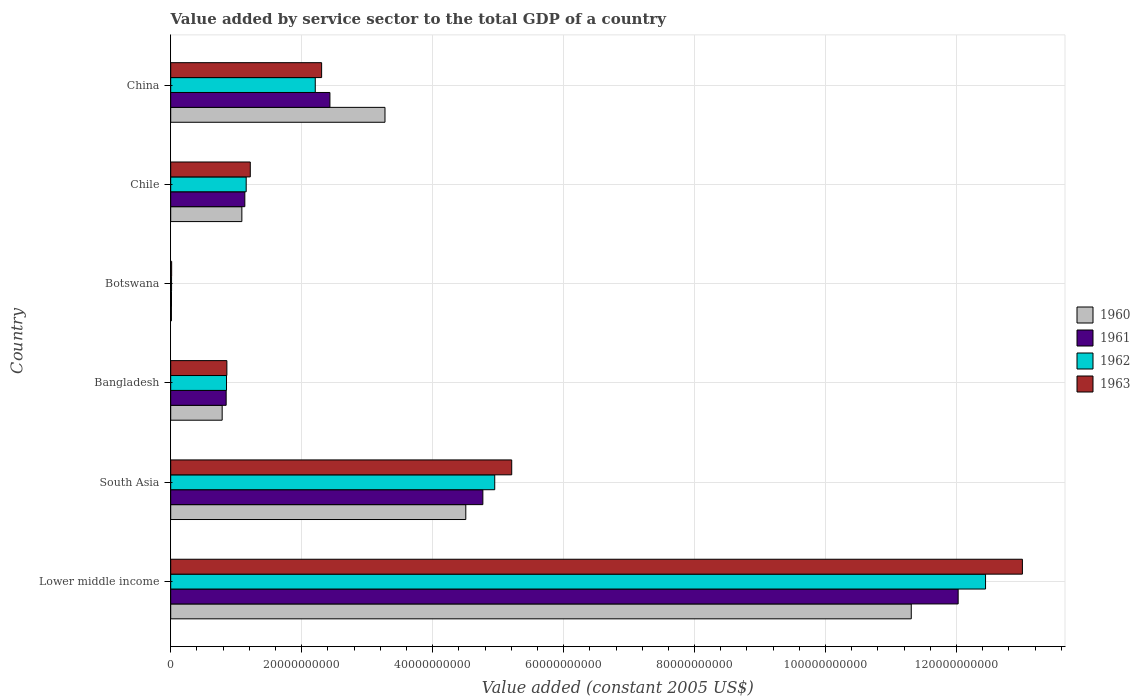Are the number of bars on each tick of the Y-axis equal?
Offer a terse response. Yes. What is the label of the 6th group of bars from the top?
Make the answer very short. Lower middle income. In how many cases, is the number of bars for a given country not equal to the number of legend labels?
Provide a succinct answer. 0. What is the value added by service sector in 1960 in Botswana?
Keep it short and to the point. 1.11e+08. Across all countries, what is the maximum value added by service sector in 1961?
Keep it short and to the point. 1.20e+11. Across all countries, what is the minimum value added by service sector in 1960?
Make the answer very short. 1.11e+08. In which country was the value added by service sector in 1961 maximum?
Ensure brevity in your answer.  Lower middle income. In which country was the value added by service sector in 1960 minimum?
Your answer should be very brief. Botswana. What is the total value added by service sector in 1961 in the graph?
Provide a succinct answer. 2.12e+11. What is the difference between the value added by service sector in 1962 in Bangladesh and that in South Asia?
Provide a succinct answer. -4.10e+1. What is the difference between the value added by service sector in 1961 in Botswana and the value added by service sector in 1960 in China?
Your response must be concise. -3.26e+1. What is the average value added by service sector in 1963 per country?
Keep it short and to the point. 3.77e+1. What is the difference between the value added by service sector in 1963 and value added by service sector in 1961 in Botswana?
Make the answer very short. 2.33e+07. What is the ratio of the value added by service sector in 1962 in Bangladesh to that in China?
Your response must be concise. 0.39. Is the value added by service sector in 1962 in Bangladesh less than that in Botswana?
Give a very brief answer. No. What is the difference between the highest and the second highest value added by service sector in 1960?
Give a very brief answer. 6.80e+1. What is the difference between the highest and the lowest value added by service sector in 1961?
Offer a terse response. 1.20e+11. Is it the case that in every country, the sum of the value added by service sector in 1960 and value added by service sector in 1962 is greater than the sum of value added by service sector in 1963 and value added by service sector in 1961?
Keep it short and to the point. No. What does the 1st bar from the top in China represents?
Offer a terse response. 1963. What does the 4th bar from the bottom in Botswana represents?
Make the answer very short. 1963. Is it the case that in every country, the sum of the value added by service sector in 1963 and value added by service sector in 1962 is greater than the value added by service sector in 1961?
Your answer should be very brief. Yes. How many bars are there?
Your response must be concise. 24. How many countries are there in the graph?
Your answer should be compact. 6. What is the difference between two consecutive major ticks on the X-axis?
Make the answer very short. 2.00e+1. Does the graph contain grids?
Keep it short and to the point. Yes. What is the title of the graph?
Give a very brief answer. Value added by service sector to the total GDP of a country. What is the label or title of the X-axis?
Keep it short and to the point. Value added (constant 2005 US$). What is the label or title of the Y-axis?
Give a very brief answer. Country. What is the Value added (constant 2005 US$) of 1960 in Lower middle income?
Provide a succinct answer. 1.13e+11. What is the Value added (constant 2005 US$) of 1961 in Lower middle income?
Your answer should be very brief. 1.20e+11. What is the Value added (constant 2005 US$) in 1962 in Lower middle income?
Keep it short and to the point. 1.24e+11. What is the Value added (constant 2005 US$) in 1963 in Lower middle income?
Make the answer very short. 1.30e+11. What is the Value added (constant 2005 US$) in 1960 in South Asia?
Make the answer very short. 4.51e+1. What is the Value added (constant 2005 US$) in 1961 in South Asia?
Provide a succinct answer. 4.77e+1. What is the Value added (constant 2005 US$) in 1962 in South Asia?
Offer a terse response. 4.95e+1. What is the Value added (constant 2005 US$) in 1963 in South Asia?
Give a very brief answer. 5.21e+1. What is the Value added (constant 2005 US$) in 1960 in Bangladesh?
Make the answer very short. 7.86e+09. What is the Value added (constant 2005 US$) in 1961 in Bangladesh?
Offer a very short reply. 8.47e+09. What is the Value added (constant 2005 US$) of 1962 in Bangladesh?
Provide a short and direct response. 8.52e+09. What is the Value added (constant 2005 US$) in 1963 in Bangladesh?
Give a very brief answer. 8.58e+09. What is the Value added (constant 2005 US$) in 1960 in Botswana?
Keep it short and to the point. 1.11e+08. What is the Value added (constant 2005 US$) of 1961 in Botswana?
Offer a terse response. 1.22e+08. What is the Value added (constant 2005 US$) in 1962 in Botswana?
Keep it short and to the point. 1.32e+08. What is the Value added (constant 2005 US$) in 1963 in Botswana?
Your answer should be compact. 1.45e+08. What is the Value added (constant 2005 US$) of 1960 in Chile?
Offer a very short reply. 1.09e+1. What is the Value added (constant 2005 US$) in 1961 in Chile?
Make the answer very short. 1.13e+1. What is the Value added (constant 2005 US$) of 1962 in Chile?
Your answer should be compact. 1.15e+1. What is the Value added (constant 2005 US$) in 1963 in Chile?
Make the answer very short. 1.22e+1. What is the Value added (constant 2005 US$) of 1960 in China?
Your answer should be very brief. 3.27e+1. What is the Value added (constant 2005 US$) in 1961 in China?
Give a very brief answer. 2.43e+1. What is the Value added (constant 2005 US$) of 1962 in China?
Provide a short and direct response. 2.21e+1. What is the Value added (constant 2005 US$) in 1963 in China?
Make the answer very short. 2.30e+1. Across all countries, what is the maximum Value added (constant 2005 US$) in 1960?
Your answer should be very brief. 1.13e+11. Across all countries, what is the maximum Value added (constant 2005 US$) of 1961?
Offer a terse response. 1.20e+11. Across all countries, what is the maximum Value added (constant 2005 US$) in 1962?
Make the answer very short. 1.24e+11. Across all countries, what is the maximum Value added (constant 2005 US$) in 1963?
Offer a very short reply. 1.30e+11. Across all countries, what is the minimum Value added (constant 2005 US$) of 1960?
Make the answer very short. 1.11e+08. Across all countries, what is the minimum Value added (constant 2005 US$) of 1961?
Offer a terse response. 1.22e+08. Across all countries, what is the minimum Value added (constant 2005 US$) in 1962?
Provide a short and direct response. 1.32e+08. Across all countries, what is the minimum Value added (constant 2005 US$) in 1963?
Give a very brief answer. 1.45e+08. What is the total Value added (constant 2005 US$) in 1960 in the graph?
Make the answer very short. 2.10e+11. What is the total Value added (constant 2005 US$) in 1961 in the graph?
Your response must be concise. 2.12e+11. What is the total Value added (constant 2005 US$) in 1962 in the graph?
Make the answer very short. 2.16e+11. What is the total Value added (constant 2005 US$) of 1963 in the graph?
Give a very brief answer. 2.26e+11. What is the difference between the Value added (constant 2005 US$) in 1960 in Lower middle income and that in South Asia?
Make the answer very short. 6.80e+1. What is the difference between the Value added (constant 2005 US$) in 1961 in Lower middle income and that in South Asia?
Your answer should be very brief. 7.26e+1. What is the difference between the Value added (constant 2005 US$) of 1962 in Lower middle income and that in South Asia?
Keep it short and to the point. 7.50e+1. What is the difference between the Value added (constant 2005 US$) in 1963 in Lower middle income and that in South Asia?
Ensure brevity in your answer.  7.80e+1. What is the difference between the Value added (constant 2005 US$) in 1960 in Lower middle income and that in Bangladesh?
Provide a succinct answer. 1.05e+11. What is the difference between the Value added (constant 2005 US$) in 1961 in Lower middle income and that in Bangladesh?
Provide a succinct answer. 1.12e+11. What is the difference between the Value added (constant 2005 US$) of 1962 in Lower middle income and that in Bangladesh?
Provide a succinct answer. 1.16e+11. What is the difference between the Value added (constant 2005 US$) in 1963 in Lower middle income and that in Bangladesh?
Your response must be concise. 1.21e+11. What is the difference between the Value added (constant 2005 US$) of 1960 in Lower middle income and that in Botswana?
Ensure brevity in your answer.  1.13e+11. What is the difference between the Value added (constant 2005 US$) of 1961 in Lower middle income and that in Botswana?
Give a very brief answer. 1.20e+11. What is the difference between the Value added (constant 2005 US$) in 1962 in Lower middle income and that in Botswana?
Keep it short and to the point. 1.24e+11. What is the difference between the Value added (constant 2005 US$) of 1963 in Lower middle income and that in Botswana?
Give a very brief answer. 1.30e+11. What is the difference between the Value added (constant 2005 US$) in 1960 in Lower middle income and that in Chile?
Offer a terse response. 1.02e+11. What is the difference between the Value added (constant 2005 US$) in 1961 in Lower middle income and that in Chile?
Offer a very short reply. 1.09e+11. What is the difference between the Value added (constant 2005 US$) in 1962 in Lower middle income and that in Chile?
Offer a very short reply. 1.13e+11. What is the difference between the Value added (constant 2005 US$) of 1963 in Lower middle income and that in Chile?
Provide a short and direct response. 1.18e+11. What is the difference between the Value added (constant 2005 US$) in 1960 in Lower middle income and that in China?
Provide a succinct answer. 8.04e+1. What is the difference between the Value added (constant 2005 US$) of 1961 in Lower middle income and that in China?
Provide a succinct answer. 9.59e+1. What is the difference between the Value added (constant 2005 US$) in 1962 in Lower middle income and that in China?
Ensure brevity in your answer.  1.02e+11. What is the difference between the Value added (constant 2005 US$) in 1963 in Lower middle income and that in China?
Your response must be concise. 1.07e+11. What is the difference between the Value added (constant 2005 US$) of 1960 in South Asia and that in Bangladesh?
Keep it short and to the point. 3.72e+1. What is the difference between the Value added (constant 2005 US$) in 1961 in South Asia and that in Bangladesh?
Provide a succinct answer. 3.92e+1. What is the difference between the Value added (constant 2005 US$) in 1962 in South Asia and that in Bangladesh?
Keep it short and to the point. 4.10e+1. What is the difference between the Value added (constant 2005 US$) of 1963 in South Asia and that in Bangladesh?
Your response must be concise. 4.35e+1. What is the difference between the Value added (constant 2005 US$) of 1960 in South Asia and that in Botswana?
Keep it short and to the point. 4.50e+1. What is the difference between the Value added (constant 2005 US$) in 1961 in South Asia and that in Botswana?
Ensure brevity in your answer.  4.75e+1. What is the difference between the Value added (constant 2005 US$) of 1962 in South Asia and that in Botswana?
Provide a succinct answer. 4.93e+1. What is the difference between the Value added (constant 2005 US$) in 1963 in South Asia and that in Botswana?
Your answer should be compact. 5.19e+1. What is the difference between the Value added (constant 2005 US$) of 1960 in South Asia and that in Chile?
Your response must be concise. 3.42e+1. What is the difference between the Value added (constant 2005 US$) of 1961 in South Asia and that in Chile?
Give a very brief answer. 3.63e+1. What is the difference between the Value added (constant 2005 US$) in 1962 in South Asia and that in Chile?
Provide a short and direct response. 3.80e+1. What is the difference between the Value added (constant 2005 US$) of 1963 in South Asia and that in Chile?
Make the answer very short. 3.99e+1. What is the difference between the Value added (constant 2005 US$) of 1960 in South Asia and that in China?
Provide a short and direct response. 1.23e+1. What is the difference between the Value added (constant 2005 US$) in 1961 in South Asia and that in China?
Keep it short and to the point. 2.34e+1. What is the difference between the Value added (constant 2005 US$) of 1962 in South Asia and that in China?
Provide a short and direct response. 2.74e+1. What is the difference between the Value added (constant 2005 US$) of 1963 in South Asia and that in China?
Your answer should be compact. 2.90e+1. What is the difference between the Value added (constant 2005 US$) in 1960 in Bangladesh and that in Botswana?
Your answer should be compact. 7.75e+09. What is the difference between the Value added (constant 2005 US$) of 1961 in Bangladesh and that in Botswana?
Your response must be concise. 8.35e+09. What is the difference between the Value added (constant 2005 US$) of 1962 in Bangladesh and that in Botswana?
Offer a terse response. 8.39e+09. What is the difference between the Value added (constant 2005 US$) in 1963 in Bangladesh and that in Botswana?
Your answer should be very brief. 8.43e+09. What is the difference between the Value added (constant 2005 US$) of 1960 in Bangladesh and that in Chile?
Provide a short and direct response. -3.01e+09. What is the difference between the Value added (constant 2005 US$) in 1961 in Bangladesh and that in Chile?
Provide a succinct answer. -2.85e+09. What is the difference between the Value added (constant 2005 US$) in 1962 in Bangladesh and that in Chile?
Make the answer very short. -3.00e+09. What is the difference between the Value added (constant 2005 US$) of 1963 in Bangladesh and that in Chile?
Make the answer very short. -3.58e+09. What is the difference between the Value added (constant 2005 US$) in 1960 in Bangladesh and that in China?
Offer a terse response. -2.49e+1. What is the difference between the Value added (constant 2005 US$) in 1961 in Bangladesh and that in China?
Your answer should be compact. -1.58e+1. What is the difference between the Value added (constant 2005 US$) in 1962 in Bangladesh and that in China?
Offer a terse response. -1.36e+1. What is the difference between the Value added (constant 2005 US$) of 1963 in Bangladesh and that in China?
Provide a succinct answer. -1.45e+1. What is the difference between the Value added (constant 2005 US$) of 1960 in Botswana and that in Chile?
Keep it short and to the point. -1.08e+1. What is the difference between the Value added (constant 2005 US$) in 1961 in Botswana and that in Chile?
Your answer should be very brief. -1.12e+1. What is the difference between the Value added (constant 2005 US$) of 1962 in Botswana and that in Chile?
Offer a terse response. -1.14e+1. What is the difference between the Value added (constant 2005 US$) of 1963 in Botswana and that in Chile?
Your response must be concise. -1.20e+1. What is the difference between the Value added (constant 2005 US$) in 1960 in Botswana and that in China?
Offer a very short reply. -3.26e+1. What is the difference between the Value added (constant 2005 US$) in 1961 in Botswana and that in China?
Offer a terse response. -2.42e+1. What is the difference between the Value added (constant 2005 US$) in 1962 in Botswana and that in China?
Your response must be concise. -2.19e+1. What is the difference between the Value added (constant 2005 US$) in 1963 in Botswana and that in China?
Provide a succinct answer. -2.29e+1. What is the difference between the Value added (constant 2005 US$) in 1960 in Chile and that in China?
Your response must be concise. -2.19e+1. What is the difference between the Value added (constant 2005 US$) in 1961 in Chile and that in China?
Offer a terse response. -1.30e+1. What is the difference between the Value added (constant 2005 US$) in 1962 in Chile and that in China?
Offer a terse response. -1.05e+1. What is the difference between the Value added (constant 2005 US$) of 1963 in Chile and that in China?
Provide a short and direct response. -1.09e+1. What is the difference between the Value added (constant 2005 US$) of 1960 in Lower middle income and the Value added (constant 2005 US$) of 1961 in South Asia?
Provide a short and direct response. 6.54e+1. What is the difference between the Value added (constant 2005 US$) in 1960 in Lower middle income and the Value added (constant 2005 US$) in 1962 in South Asia?
Keep it short and to the point. 6.36e+1. What is the difference between the Value added (constant 2005 US$) of 1960 in Lower middle income and the Value added (constant 2005 US$) of 1963 in South Asia?
Your response must be concise. 6.10e+1. What is the difference between the Value added (constant 2005 US$) in 1961 in Lower middle income and the Value added (constant 2005 US$) in 1962 in South Asia?
Your answer should be compact. 7.08e+1. What is the difference between the Value added (constant 2005 US$) in 1961 in Lower middle income and the Value added (constant 2005 US$) in 1963 in South Asia?
Offer a very short reply. 6.82e+1. What is the difference between the Value added (constant 2005 US$) in 1962 in Lower middle income and the Value added (constant 2005 US$) in 1963 in South Asia?
Give a very brief answer. 7.24e+1. What is the difference between the Value added (constant 2005 US$) of 1960 in Lower middle income and the Value added (constant 2005 US$) of 1961 in Bangladesh?
Make the answer very short. 1.05e+11. What is the difference between the Value added (constant 2005 US$) in 1960 in Lower middle income and the Value added (constant 2005 US$) in 1962 in Bangladesh?
Keep it short and to the point. 1.05e+11. What is the difference between the Value added (constant 2005 US$) in 1960 in Lower middle income and the Value added (constant 2005 US$) in 1963 in Bangladesh?
Provide a succinct answer. 1.05e+11. What is the difference between the Value added (constant 2005 US$) in 1961 in Lower middle income and the Value added (constant 2005 US$) in 1962 in Bangladesh?
Your answer should be very brief. 1.12e+11. What is the difference between the Value added (constant 2005 US$) of 1961 in Lower middle income and the Value added (constant 2005 US$) of 1963 in Bangladesh?
Make the answer very short. 1.12e+11. What is the difference between the Value added (constant 2005 US$) in 1962 in Lower middle income and the Value added (constant 2005 US$) in 1963 in Bangladesh?
Offer a very short reply. 1.16e+11. What is the difference between the Value added (constant 2005 US$) in 1960 in Lower middle income and the Value added (constant 2005 US$) in 1961 in Botswana?
Offer a terse response. 1.13e+11. What is the difference between the Value added (constant 2005 US$) in 1960 in Lower middle income and the Value added (constant 2005 US$) in 1962 in Botswana?
Provide a succinct answer. 1.13e+11. What is the difference between the Value added (constant 2005 US$) of 1960 in Lower middle income and the Value added (constant 2005 US$) of 1963 in Botswana?
Offer a terse response. 1.13e+11. What is the difference between the Value added (constant 2005 US$) of 1961 in Lower middle income and the Value added (constant 2005 US$) of 1962 in Botswana?
Your answer should be very brief. 1.20e+11. What is the difference between the Value added (constant 2005 US$) of 1961 in Lower middle income and the Value added (constant 2005 US$) of 1963 in Botswana?
Keep it short and to the point. 1.20e+11. What is the difference between the Value added (constant 2005 US$) of 1962 in Lower middle income and the Value added (constant 2005 US$) of 1963 in Botswana?
Your response must be concise. 1.24e+11. What is the difference between the Value added (constant 2005 US$) of 1960 in Lower middle income and the Value added (constant 2005 US$) of 1961 in Chile?
Ensure brevity in your answer.  1.02e+11. What is the difference between the Value added (constant 2005 US$) of 1960 in Lower middle income and the Value added (constant 2005 US$) of 1962 in Chile?
Offer a terse response. 1.02e+11. What is the difference between the Value added (constant 2005 US$) of 1960 in Lower middle income and the Value added (constant 2005 US$) of 1963 in Chile?
Provide a short and direct response. 1.01e+11. What is the difference between the Value added (constant 2005 US$) in 1961 in Lower middle income and the Value added (constant 2005 US$) in 1962 in Chile?
Ensure brevity in your answer.  1.09e+11. What is the difference between the Value added (constant 2005 US$) in 1961 in Lower middle income and the Value added (constant 2005 US$) in 1963 in Chile?
Your response must be concise. 1.08e+11. What is the difference between the Value added (constant 2005 US$) of 1962 in Lower middle income and the Value added (constant 2005 US$) of 1963 in Chile?
Your response must be concise. 1.12e+11. What is the difference between the Value added (constant 2005 US$) in 1960 in Lower middle income and the Value added (constant 2005 US$) in 1961 in China?
Provide a short and direct response. 8.88e+1. What is the difference between the Value added (constant 2005 US$) in 1960 in Lower middle income and the Value added (constant 2005 US$) in 1962 in China?
Your answer should be compact. 9.10e+1. What is the difference between the Value added (constant 2005 US$) in 1960 in Lower middle income and the Value added (constant 2005 US$) in 1963 in China?
Your response must be concise. 9.00e+1. What is the difference between the Value added (constant 2005 US$) of 1961 in Lower middle income and the Value added (constant 2005 US$) of 1962 in China?
Provide a short and direct response. 9.82e+1. What is the difference between the Value added (constant 2005 US$) in 1961 in Lower middle income and the Value added (constant 2005 US$) in 1963 in China?
Your answer should be very brief. 9.72e+1. What is the difference between the Value added (constant 2005 US$) in 1962 in Lower middle income and the Value added (constant 2005 US$) in 1963 in China?
Provide a succinct answer. 1.01e+11. What is the difference between the Value added (constant 2005 US$) in 1960 in South Asia and the Value added (constant 2005 US$) in 1961 in Bangladesh?
Make the answer very short. 3.66e+1. What is the difference between the Value added (constant 2005 US$) of 1960 in South Asia and the Value added (constant 2005 US$) of 1962 in Bangladesh?
Your answer should be very brief. 3.65e+1. What is the difference between the Value added (constant 2005 US$) of 1960 in South Asia and the Value added (constant 2005 US$) of 1963 in Bangladesh?
Provide a short and direct response. 3.65e+1. What is the difference between the Value added (constant 2005 US$) of 1961 in South Asia and the Value added (constant 2005 US$) of 1962 in Bangladesh?
Give a very brief answer. 3.91e+1. What is the difference between the Value added (constant 2005 US$) in 1961 in South Asia and the Value added (constant 2005 US$) in 1963 in Bangladesh?
Your answer should be compact. 3.91e+1. What is the difference between the Value added (constant 2005 US$) in 1962 in South Asia and the Value added (constant 2005 US$) in 1963 in Bangladesh?
Your answer should be compact. 4.09e+1. What is the difference between the Value added (constant 2005 US$) in 1960 in South Asia and the Value added (constant 2005 US$) in 1961 in Botswana?
Offer a terse response. 4.49e+1. What is the difference between the Value added (constant 2005 US$) of 1960 in South Asia and the Value added (constant 2005 US$) of 1962 in Botswana?
Your response must be concise. 4.49e+1. What is the difference between the Value added (constant 2005 US$) of 1960 in South Asia and the Value added (constant 2005 US$) of 1963 in Botswana?
Your answer should be compact. 4.49e+1. What is the difference between the Value added (constant 2005 US$) in 1961 in South Asia and the Value added (constant 2005 US$) in 1962 in Botswana?
Ensure brevity in your answer.  4.75e+1. What is the difference between the Value added (constant 2005 US$) in 1961 in South Asia and the Value added (constant 2005 US$) in 1963 in Botswana?
Offer a very short reply. 4.75e+1. What is the difference between the Value added (constant 2005 US$) of 1962 in South Asia and the Value added (constant 2005 US$) of 1963 in Botswana?
Your answer should be very brief. 4.93e+1. What is the difference between the Value added (constant 2005 US$) in 1960 in South Asia and the Value added (constant 2005 US$) in 1961 in Chile?
Make the answer very short. 3.37e+1. What is the difference between the Value added (constant 2005 US$) of 1960 in South Asia and the Value added (constant 2005 US$) of 1962 in Chile?
Your answer should be compact. 3.35e+1. What is the difference between the Value added (constant 2005 US$) in 1960 in South Asia and the Value added (constant 2005 US$) in 1963 in Chile?
Offer a very short reply. 3.29e+1. What is the difference between the Value added (constant 2005 US$) of 1961 in South Asia and the Value added (constant 2005 US$) of 1962 in Chile?
Provide a succinct answer. 3.61e+1. What is the difference between the Value added (constant 2005 US$) of 1961 in South Asia and the Value added (constant 2005 US$) of 1963 in Chile?
Offer a very short reply. 3.55e+1. What is the difference between the Value added (constant 2005 US$) of 1962 in South Asia and the Value added (constant 2005 US$) of 1963 in Chile?
Provide a succinct answer. 3.73e+1. What is the difference between the Value added (constant 2005 US$) in 1960 in South Asia and the Value added (constant 2005 US$) in 1961 in China?
Make the answer very short. 2.08e+1. What is the difference between the Value added (constant 2005 US$) in 1960 in South Asia and the Value added (constant 2005 US$) in 1962 in China?
Make the answer very short. 2.30e+1. What is the difference between the Value added (constant 2005 US$) of 1960 in South Asia and the Value added (constant 2005 US$) of 1963 in China?
Provide a short and direct response. 2.20e+1. What is the difference between the Value added (constant 2005 US$) of 1961 in South Asia and the Value added (constant 2005 US$) of 1962 in China?
Ensure brevity in your answer.  2.56e+1. What is the difference between the Value added (constant 2005 US$) in 1961 in South Asia and the Value added (constant 2005 US$) in 1963 in China?
Your answer should be compact. 2.46e+1. What is the difference between the Value added (constant 2005 US$) of 1962 in South Asia and the Value added (constant 2005 US$) of 1963 in China?
Give a very brief answer. 2.64e+1. What is the difference between the Value added (constant 2005 US$) of 1960 in Bangladesh and the Value added (constant 2005 US$) of 1961 in Botswana?
Offer a very short reply. 7.74e+09. What is the difference between the Value added (constant 2005 US$) of 1960 in Bangladesh and the Value added (constant 2005 US$) of 1962 in Botswana?
Your answer should be compact. 7.73e+09. What is the difference between the Value added (constant 2005 US$) of 1960 in Bangladesh and the Value added (constant 2005 US$) of 1963 in Botswana?
Give a very brief answer. 7.72e+09. What is the difference between the Value added (constant 2005 US$) of 1961 in Bangladesh and the Value added (constant 2005 US$) of 1962 in Botswana?
Give a very brief answer. 8.34e+09. What is the difference between the Value added (constant 2005 US$) in 1961 in Bangladesh and the Value added (constant 2005 US$) in 1963 in Botswana?
Make the answer very short. 8.32e+09. What is the difference between the Value added (constant 2005 US$) in 1962 in Bangladesh and the Value added (constant 2005 US$) in 1963 in Botswana?
Offer a terse response. 8.38e+09. What is the difference between the Value added (constant 2005 US$) of 1960 in Bangladesh and the Value added (constant 2005 US$) of 1961 in Chile?
Your response must be concise. -3.46e+09. What is the difference between the Value added (constant 2005 US$) in 1960 in Bangladesh and the Value added (constant 2005 US$) in 1962 in Chile?
Your response must be concise. -3.67e+09. What is the difference between the Value added (constant 2005 US$) of 1960 in Bangladesh and the Value added (constant 2005 US$) of 1963 in Chile?
Make the answer very short. -4.29e+09. What is the difference between the Value added (constant 2005 US$) of 1961 in Bangladesh and the Value added (constant 2005 US$) of 1962 in Chile?
Provide a succinct answer. -3.06e+09. What is the difference between the Value added (constant 2005 US$) of 1961 in Bangladesh and the Value added (constant 2005 US$) of 1963 in Chile?
Your answer should be very brief. -3.68e+09. What is the difference between the Value added (constant 2005 US$) of 1962 in Bangladesh and the Value added (constant 2005 US$) of 1963 in Chile?
Provide a succinct answer. -3.63e+09. What is the difference between the Value added (constant 2005 US$) in 1960 in Bangladesh and the Value added (constant 2005 US$) in 1961 in China?
Offer a very short reply. -1.65e+1. What is the difference between the Value added (constant 2005 US$) in 1960 in Bangladesh and the Value added (constant 2005 US$) in 1962 in China?
Ensure brevity in your answer.  -1.42e+1. What is the difference between the Value added (constant 2005 US$) in 1960 in Bangladesh and the Value added (constant 2005 US$) in 1963 in China?
Provide a short and direct response. -1.52e+1. What is the difference between the Value added (constant 2005 US$) in 1961 in Bangladesh and the Value added (constant 2005 US$) in 1962 in China?
Give a very brief answer. -1.36e+1. What is the difference between the Value added (constant 2005 US$) of 1961 in Bangladesh and the Value added (constant 2005 US$) of 1963 in China?
Keep it short and to the point. -1.46e+1. What is the difference between the Value added (constant 2005 US$) of 1962 in Bangladesh and the Value added (constant 2005 US$) of 1963 in China?
Ensure brevity in your answer.  -1.45e+1. What is the difference between the Value added (constant 2005 US$) in 1960 in Botswana and the Value added (constant 2005 US$) in 1961 in Chile?
Your response must be concise. -1.12e+1. What is the difference between the Value added (constant 2005 US$) of 1960 in Botswana and the Value added (constant 2005 US$) of 1962 in Chile?
Provide a succinct answer. -1.14e+1. What is the difference between the Value added (constant 2005 US$) of 1960 in Botswana and the Value added (constant 2005 US$) of 1963 in Chile?
Ensure brevity in your answer.  -1.20e+1. What is the difference between the Value added (constant 2005 US$) in 1961 in Botswana and the Value added (constant 2005 US$) in 1962 in Chile?
Ensure brevity in your answer.  -1.14e+1. What is the difference between the Value added (constant 2005 US$) in 1961 in Botswana and the Value added (constant 2005 US$) in 1963 in Chile?
Your response must be concise. -1.20e+1. What is the difference between the Value added (constant 2005 US$) of 1962 in Botswana and the Value added (constant 2005 US$) of 1963 in Chile?
Ensure brevity in your answer.  -1.20e+1. What is the difference between the Value added (constant 2005 US$) of 1960 in Botswana and the Value added (constant 2005 US$) of 1961 in China?
Provide a succinct answer. -2.42e+1. What is the difference between the Value added (constant 2005 US$) of 1960 in Botswana and the Value added (constant 2005 US$) of 1962 in China?
Ensure brevity in your answer.  -2.20e+1. What is the difference between the Value added (constant 2005 US$) of 1960 in Botswana and the Value added (constant 2005 US$) of 1963 in China?
Make the answer very short. -2.29e+1. What is the difference between the Value added (constant 2005 US$) of 1961 in Botswana and the Value added (constant 2005 US$) of 1962 in China?
Your response must be concise. -2.20e+1. What is the difference between the Value added (constant 2005 US$) in 1961 in Botswana and the Value added (constant 2005 US$) in 1963 in China?
Keep it short and to the point. -2.29e+1. What is the difference between the Value added (constant 2005 US$) in 1962 in Botswana and the Value added (constant 2005 US$) in 1963 in China?
Offer a terse response. -2.29e+1. What is the difference between the Value added (constant 2005 US$) in 1960 in Chile and the Value added (constant 2005 US$) in 1961 in China?
Make the answer very short. -1.34e+1. What is the difference between the Value added (constant 2005 US$) of 1960 in Chile and the Value added (constant 2005 US$) of 1962 in China?
Ensure brevity in your answer.  -1.12e+1. What is the difference between the Value added (constant 2005 US$) in 1960 in Chile and the Value added (constant 2005 US$) in 1963 in China?
Make the answer very short. -1.22e+1. What is the difference between the Value added (constant 2005 US$) in 1961 in Chile and the Value added (constant 2005 US$) in 1962 in China?
Ensure brevity in your answer.  -1.08e+1. What is the difference between the Value added (constant 2005 US$) of 1961 in Chile and the Value added (constant 2005 US$) of 1963 in China?
Provide a succinct answer. -1.17e+1. What is the difference between the Value added (constant 2005 US$) of 1962 in Chile and the Value added (constant 2005 US$) of 1963 in China?
Ensure brevity in your answer.  -1.15e+1. What is the average Value added (constant 2005 US$) in 1960 per country?
Make the answer very short. 3.50e+1. What is the average Value added (constant 2005 US$) of 1961 per country?
Keep it short and to the point. 3.54e+1. What is the average Value added (constant 2005 US$) in 1962 per country?
Offer a terse response. 3.60e+1. What is the average Value added (constant 2005 US$) in 1963 per country?
Ensure brevity in your answer.  3.77e+1. What is the difference between the Value added (constant 2005 US$) of 1960 and Value added (constant 2005 US$) of 1961 in Lower middle income?
Offer a very short reply. -7.16e+09. What is the difference between the Value added (constant 2005 US$) of 1960 and Value added (constant 2005 US$) of 1962 in Lower middle income?
Offer a terse response. -1.13e+1. What is the difference between the Value added (constant 2005 US$) in 1960 and Value added (constant 2005 US$) in 1963 in Lower middle income?
Offer a very short reply. -1.70e+1. What is the difference between the Value added (constant 2005 US$) of 1961 and Value added (constant 2005 US$) of 1962 in Lower middle income?
Your response must be concise. -4.18e+09. What is the difference between the Value added (constant 2005 US$) in 1961 and Value added (constant 2005 US$) in 1963 in Lower middle income?
Your answer should be very brief. -9.81e+09. What is the difference between the Value added (constant 2005 US$) in 1962 and Value added (constant 2005 US$) in 1963 in Lower middle income?
Offer a very short reply. -5.63e+09. What is the difference between the Value added (constant 2005 US$) in 1960 and Value added (constant 2005 US$) in 1961 in South Asia?
Your response must be concise. -2.61e+09. What is the difference between the Value added (constant 2005 US$) of 1960 and Value added (constant 2005 US$) of 1962 in South Asia?
Offer a very short reply. -4.42e+09. What is the difference between the Value added (constant 2005 US$) in 1960 and Value added (constant 2005 US$) in 1963 in South Asia?
Your answer should be compact. -7.01e+09. What is the difference between the Value added (constant 2005 US$) in 1961 and Value added (constant 2005 US$) in 1962 in South Asia?
Offer a very short reply. -1.81e+09. What is the difference between the Value added (constant 2005 US$) in 1961 and Value added (constant 2005 US$) in 1963 in South Asia?
Your response must be concise. -4.41e+09. What is the difference between the Value added (constant 2005 US$) in 1962 and Value added (constant 2005 US$) in 1963 in South Asia?
Your response must be concise. -2.59e+09. What is the difference between the Value added (constant 2005 US$) of 1960 and Value added (constant 2005 US$) of 1961 in Bangladesh?
Provide a succinct answer. -6.09e+08. What is the difference between the Value added (constant 2005 US$) in 1960 and Value added (constant 2005 US$) in 1962 in Bangladesh?
Offer a very short reply. -6.62e+08. What is the difference between the Value added (constant 2005 US$) of 1960 and Value added (constant 2005 US$) of 1963 in Bangladesh?
Your response must be concise. -7.16e+08. What is the difference between the Value added (constant 2005 US$) in 1961 and Value added (constant 2005 US$) in 1962 in Bangladesh?
Give a very brief answer. -5.33e+07. What is the difference between the Value added (constant 2005 US$) in 1961 and Value added (constant 2005 US$) in 1963 in Bangladesh?
Your answer should be compact. -1.08e+08. What is the difference between the Value added (constant 2005 US$) in 1962 and Value added (constant 2005 US$) in 1963 in Bangladesh?
Your answer should be very brief. -5.45e+07. What is the difference between the Value added (constant 2005 US$) in 1960 and Value added (constant 2005 US$) in 1961 in Botswana?
Offer a very short reply. -1.12e+07. What is the difference between the Value added (constant 2005 US$) of 1960 and Value added (constant 2005 US$) of 1962 in Botswana?
Offer a terse response. -2.17e+07. What is the difference between the Value added (constant 2005 US$) in 1960 and Value added (constant 2005 US$) in 1963 in Botswana?
Offer a terse response. -3.45e+07. What is the difference between the Value added (constant 2005 US$) of 1961 and Value added (constant 2005 US$) of 1962 in Botswana?
Make the answer very short. -1.05e+07. What is the difference between the Value added (constant 2005 US$) of 1961 and Value added (constant 2005 US$) of 1963 in Botswana?
Your answer should be very brief. -2.33e+07. What is the difference between the Value added (constant 2005 US$) in 1962 and Value added (constant 2005 US$) in 1963 in Botswana?
Provide a short and direct response. -1.28e+07. What is the difference between the Value added (constant 2005 US$) in 1960 and Value added (constant 2005 US$) in 1961 in Chile?
Your answer should be very brief. -4.53e+08. What is the difference between the Value added (constant 2005 US$) in 1960 and Value added (constant 2005 US$) in 1962 in Chile?
Provide a succinct answer. -6.60e+08. What is the difference between the Value added (constant 2005 US$) of 1960 and Value added (constant 2005 US$) of 1963 in Chile?
Provide a short and direct response. -1.29e+09. What is the difference between the Value added (constant 2005 US$) in 1961 and Value added (constant 2005 US$) in 1962 in Chile?
Provide a succinct answer. -2.07e+08. What is the difference between the Value added (constant 2005 US$) in 1961 and Value added (constant 2005 US$) in 1963 in Chile?
Your answer should be compact. -8.32e+08. What is the difference between the Value added (constant 2005 US$) of 1962 and Value added (constant 2005 US$) of 1963 in Chile?
Make the answer very short. -6.25e+08. What is the difference between the Value added (constant 2005 US$) in 1960 and Value added (constant 2005 US$) in 1961 in China?
Provide a short and direct response. 8.41e+09. What is the difference between the Value added (constant 2005 US$) of 1960 and Value added (constant 2005 US$) of 1962 in China?
Your answer should be very brief. 1.06e+1. What is the difference between the Value added (constant 2005 US$) in 1960 and Value added (constant 2005 US$) in 1963 in China?
Your answer should be compact. 9.68e+09. What is the difference between the Value added (constant 2005 US$) of 1961 and Value added (constant 2005 US$) of 1962 in China?
Offer a very short reply. 2.24e+09. What is the difference between the Value added (constant 2005 US$) in 1961 and Value added (constant 2005 US$) in 1963 in China?
Provide a succinct answer. 1.27e+09. What is the difference between the Value added (constant 2005 US$) in 1962 and Value added (constant 2005 US$) in 1963 in China?
Ensure brevity in your answer.  -9.71e+08. What is the ratio of the Value added (constant 2005 US$) of 1960 in Lower middle income to that in South Asia?
Make the answer very short. 2.51. What is the ratio of the Value added (constant 2005 US$) of 1961 in Lower middle income to that in South Asia?
Keep it short and to the point. 2.52. What is the ratio of the Value added (constant 2005 US$) of 1962 in Lower middle income to that in South Asia?
Make the answer very short. 2.51. What is the ratio of the Value added (constant 2005 US$) of 1963 in Lower middle income to that in South Asia?
Keep it short and to the point. 2.5. What is the ratio of the Value added (constant 2005 US$) in 1960 in Lower middle income to that in Bangladesh?
Offer a very short reply. 14.39. What is the ratio of the Value added (constant 2005 US$) of 1961 in Lower middle income to that in Bangladesh?
Your answer should be very brief. 14.2. What is the ratio of the Value added (constant 2005 US$) in 1962 in Lower middle income to that in Bangladesh?
Keep it short and to the point. 14.6. What is the ratio of the Value added (constant 2005 US$) of 1963 in Lower middle income to that in Bangladesh?
Your response must be concise. 15.16. What is the ratio of the Value added (constant 2005 US$) in 1960 in Lower middle income to that in Botswana?
Make the answer very short. 1022.68. What is the ratio of the Value added (constant 2005 US$) of 1961 in Lower middle income to that in Botswana?
Keep it short and to the point. 987.49. What is the ratio of the Value added (constant 2005 US$) of 1962 in Lower middle income to that in Botswana?
Keep it short and to the point. 940.71. What is the ratio of the Value added (constant 2005 US$) of 1963 in Lower middle income to that in Botswana?
Keep it short and to the point. 896.5. What is the ratio of the Value added (constant 2005 US$) in 1960 in Lower middle income to that in Chile?
Provide a succinct answer. 10.41. What is the ratio of the Value added (constant 2005 US$) of 1961 in Lower middle income to that in Chile?
Your answer should be compact. 10.62. What is the ratio of the Value added (constant 2005 US$) in 1962 in Lower middle income to that in Chile?
Offer a terse response. 10.79. What is the ratio of the Value added (constant 2005 US$) of 1963 in Lower middle income to that in Chile?
Give a very brief answer. 10.7. What is the ratio of the Value added (constant 2005 US$) in 1960 in Lower middle income to that in China?
Your answer should be very brief. 3.46. What is the ratio of the Value added (constant 2005 US$) of 1961 in Lower middle income to that in China?
Your answer should be very brief. 4.95. What is the ratio of the Value added (constant 2005 US$) of 1962 in Lower middle income to that in China?
Ensure brevity in your answer.  5.64. What is the ratio of the Value added (constant 2005 US$) in 1963 in Lower middle income to that in China?
Provide a short and direct response. 5.64. What is the ratio of the Value added (constant 2005 US$) of 1960 in South Asia to that in Bangladesh?
Give a very brief answer. 5.73. What is the ratio of the Value added (constant 2005 US$) in 1961 in South Asia to that in Bangladesh?
Make the answer very short. 5.63. What is the ratio of the Value added (constant 2005 US$) in 1962 in South Asia to that in Bangladesh?
Ensure brevity in your answer.  5.81. What is the ratio of the Value added (constant 2005 US$) of 1963 in South Asia to that in Bangladesh?
Provide a succinct answer. 6.07. What is the ratio of the Value added (constant 2005 US$) in 1960 in South Asia to that in Botswana?
Your answer should be compact. 407.52. What is the ratio of the Value added (constant 2005 US$) in 1961 in South Asia to that in Botswana?
Offer a terse response. 391.45. What is the ratio of the Value added (constant 2005 US$) of 1962 in South Asia to that in Botswana?
Your answer should be very brief. 374.08. What is the ratio of the Value added (constant 2005 US$) in 1963 in South Asia to that in Botswana?
Your answer should be compact. 358.96. What is the ratio of the Value added (constant 2005 US$) of 1960 in South Asia to that in Chile?
Keep it short and to the point. 4.15. What is the ratio of the Value added (constant 2005 US$) in 1961 in South Asia to that in Chile?
Provide a succinct answer. 4.21. What is the ratio of the Value added (constant 2005 US$) of 1962 in South Asia to that in Chile?
Offer a terse response. 4.29. What is the ratio of the Value added (constant 2005 US$) in 1963 in South Asia to that in Chile?
Your answer should be very brief. 4.29. What is the ratio of the Value added (constant 2005 US$) of 1960 in South Asia to that in China?
Make the answer very short. 1.38. What is the ratio of the Value added (constant 2005 US$) of 1961 in South Asia to that in China?
Offer a very short reply. 1.96. What is the ratio of the Value added (constant 2005 US$) in 1962 in South Asia to that in China?
Offer a very short reply. 2.24. What is the ratio of the Value added (constant 2005 US$) of 1963 in South Asia to that in China?
Give a very brief answer. 2.26. What is the ratio of the Value added (constant 2005 US$) in 1960 in Bangladesh to that in Botswana?
Offer a very short reply. 71.09. What is the ratio of the Value added (constant 2005 US$) in 1961 in Bangladesh to that in Botswana?
Offer a very short reply. 69.55. What is the ratio of the Value added (constant 2005 US$) in 1962 in Bangladesh to that in Botswana?
Ensure brevity in your answer.  64.43. What is the ratio of the Value added (constant 2005 US$) of 1963 in Bangladesh to that in Botswana?
Your answer should be very brief. 59.12. What is the ratio of the Value added (constant 2005 US$) of 1960 in Bangladesh to that in Chile?
Your answer should be very brief. 0.72. What is the ratio of the Value added (constant 2005 US$) in 1961 in Bangladesh to that in Chile?
Your response must be concise. 0.75. What is the ratio of the Value added (constant 2005 US$) in 1962 in Bangladesh to that in Chile?
Ensure brevity in your answer.  0.74. What is the ratio of the Value added (constant 2005 US$) in 1963 in Bangladesh to that in Chile?
Ensure brevity in your answer.  0.71. What is the ratio of the Value added (constant 2005 US$) of 1960 in Bangladesh to that in China?
Ensure brevity in your answer.  0.24. What is the ratio of the Value added (constant 2005 US$) of 1961 in Bangladesh to that in China?
Keep it short and to the point. 0.35. What is the ratio of the Value added (constant 2005 US$) in 1962 in Bangladesh to that in China?
Offer a very short reply. 0.39. What is the ratio of the Value added (constant 2005 US$) in 1963 in Bangladesh to that in China?
Offer a terse response. 0.37. What is the ratio of the Value added (constant 2005 US$) of 1960 in Botswana to that in Chile?
Provide a short and direct response. 0.01. What is the ratio of the Value added (constant 2005 US$) of 1961 in Botswana to that in Chile?
Ensure brevity in your answer.  0.01. What is the ratio of the Value added (constant 2005 US$) of 1962 in Botswana to that in Chile?
Your answer should be very brief. 0.01. What is the ratio of the Value added (constant 2005 US$) of 1963 in Botswana to that in Chile?
Provide a short and direct response. 0.01. What is the ratio of the Value added (constant 2005 US$) of 1960 in Botswana to that in China?
Make the answer very short. 0. What is the ratio of the Value added (constant 2005 US$) in 1961 in Botswana to that in China?
Keep it short and to the point. 0.01. What is the ratio of the Value added (constant 2005 US$) in 1962 in Botswana to that in China?
Give a very brief answer. 0.01. What is the ratio of the Value added (constant 2005 US$) of 1963 in Botswana to that in China?
Make the answer very short. 0.01. What is the ratio of the Value added (constant 2005 US$) of 1960 in Chile to that in China?
Keep it short and to the point. 0.33. What is the ratio of the Value added (constant 2005 US$) in 1961 in Chile to that in China?
Your answer should be compact. 0.47. What is the ratio of the Value added (constant 2005 US$) in 1962 in Chile to that in China?
Your answer should be compact. 0.52. What is the ratio of the Value added (constant 2005 US$) in 1963 in Chile to that in China?
Provide a short and direct response. 0.53. What is the difference between the highest and the second highest Value added (constant 2005 US$) of 1960?
Your answer should be very brief. 6.80e+1. What is the difference between the highest and the second highest Value added (constant 2005 US$) in 1961?
Provide a short and direct response. 7.26e+1. What is the difference between the highest and the second highest Value added (constant 2005 US$) in 1962?
Provide a short and direct response. 7.50e+1. What is the difference between the highest and the second highest Value added (constant 2005 US$) in 1963?
Give a very brief answer. 7.80e+1. What is the difference between the highest and the lowest Value added (constant 2005 US$) in 1960?
Provide a short and direct response. 1.13e+11. What is the difference between the highest and the lowest Value added (constant 2005 US$) of 1961?
Your answer should be very brief. 1.20e+11. What is the difference between the highest and the lowest Value added (constant 2005 US$) in 1962?
Your answer should be very brief. 1.24e+11. What is the difference between the highest and the lowest Value added (constant 2005 US$) in 1963?
Provide a succinct answer. 1.30e+11. 